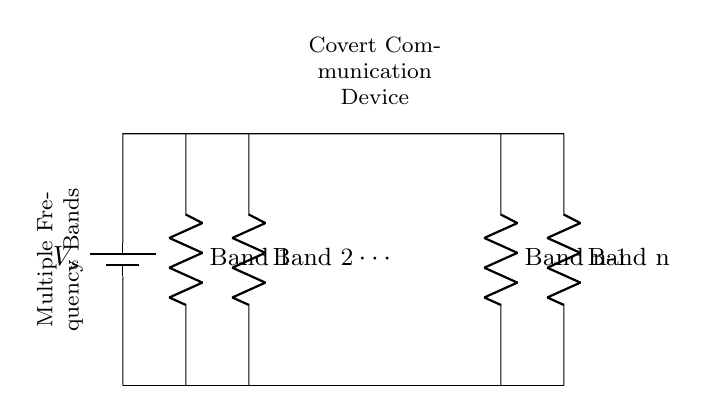What is the arrangement of the resistors in this circuit? The resistors are arranged in parallel, indicated by their vertical layout along the same voltage source. Each resistor represents a different frequency band, connected to the same points.
Answer: Parallel How many frequency bands are represented in the circuit? The circuit shows n frequency bands, as labeled on the resistors, with Band 1 through Band n. The exact number is determined by the different resistive elements displayed.
Answer: n What does each resistor represent in this circuit? Each resistor represents a different frequency band for the covert communication device, allowing the circuit to operate across multiple frequencies simultaneously.
Answer: Frequency band What are the terminals of the battery connected to? The positive terminal of the battery is connected to the top of all resistors while the negative terminal is connected to the bottom of the resistors, completing the circuit for each parallel path.
Answer: Resistors How does the voltage across each resistor compare? The voltage across each resistor is the same, as they are connected in parallel to the same voltage source, leading to equal potential difference across all branches.
Answer: Same What is the purpose of this circuit design? The purpose of this parallel circuit design is to enable covert communication across multiple frequency bands, enhancing signal versatility and reliability in a conflict zone.
Answer: Covert communication 